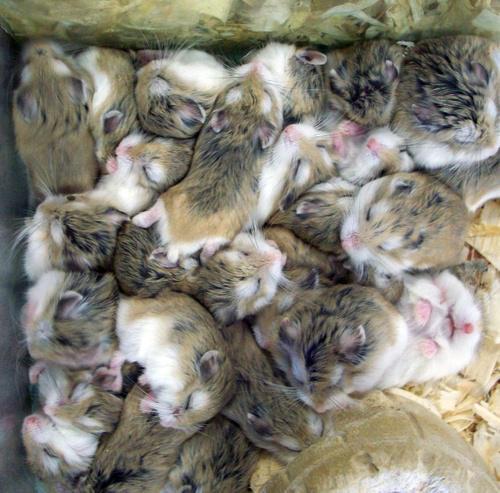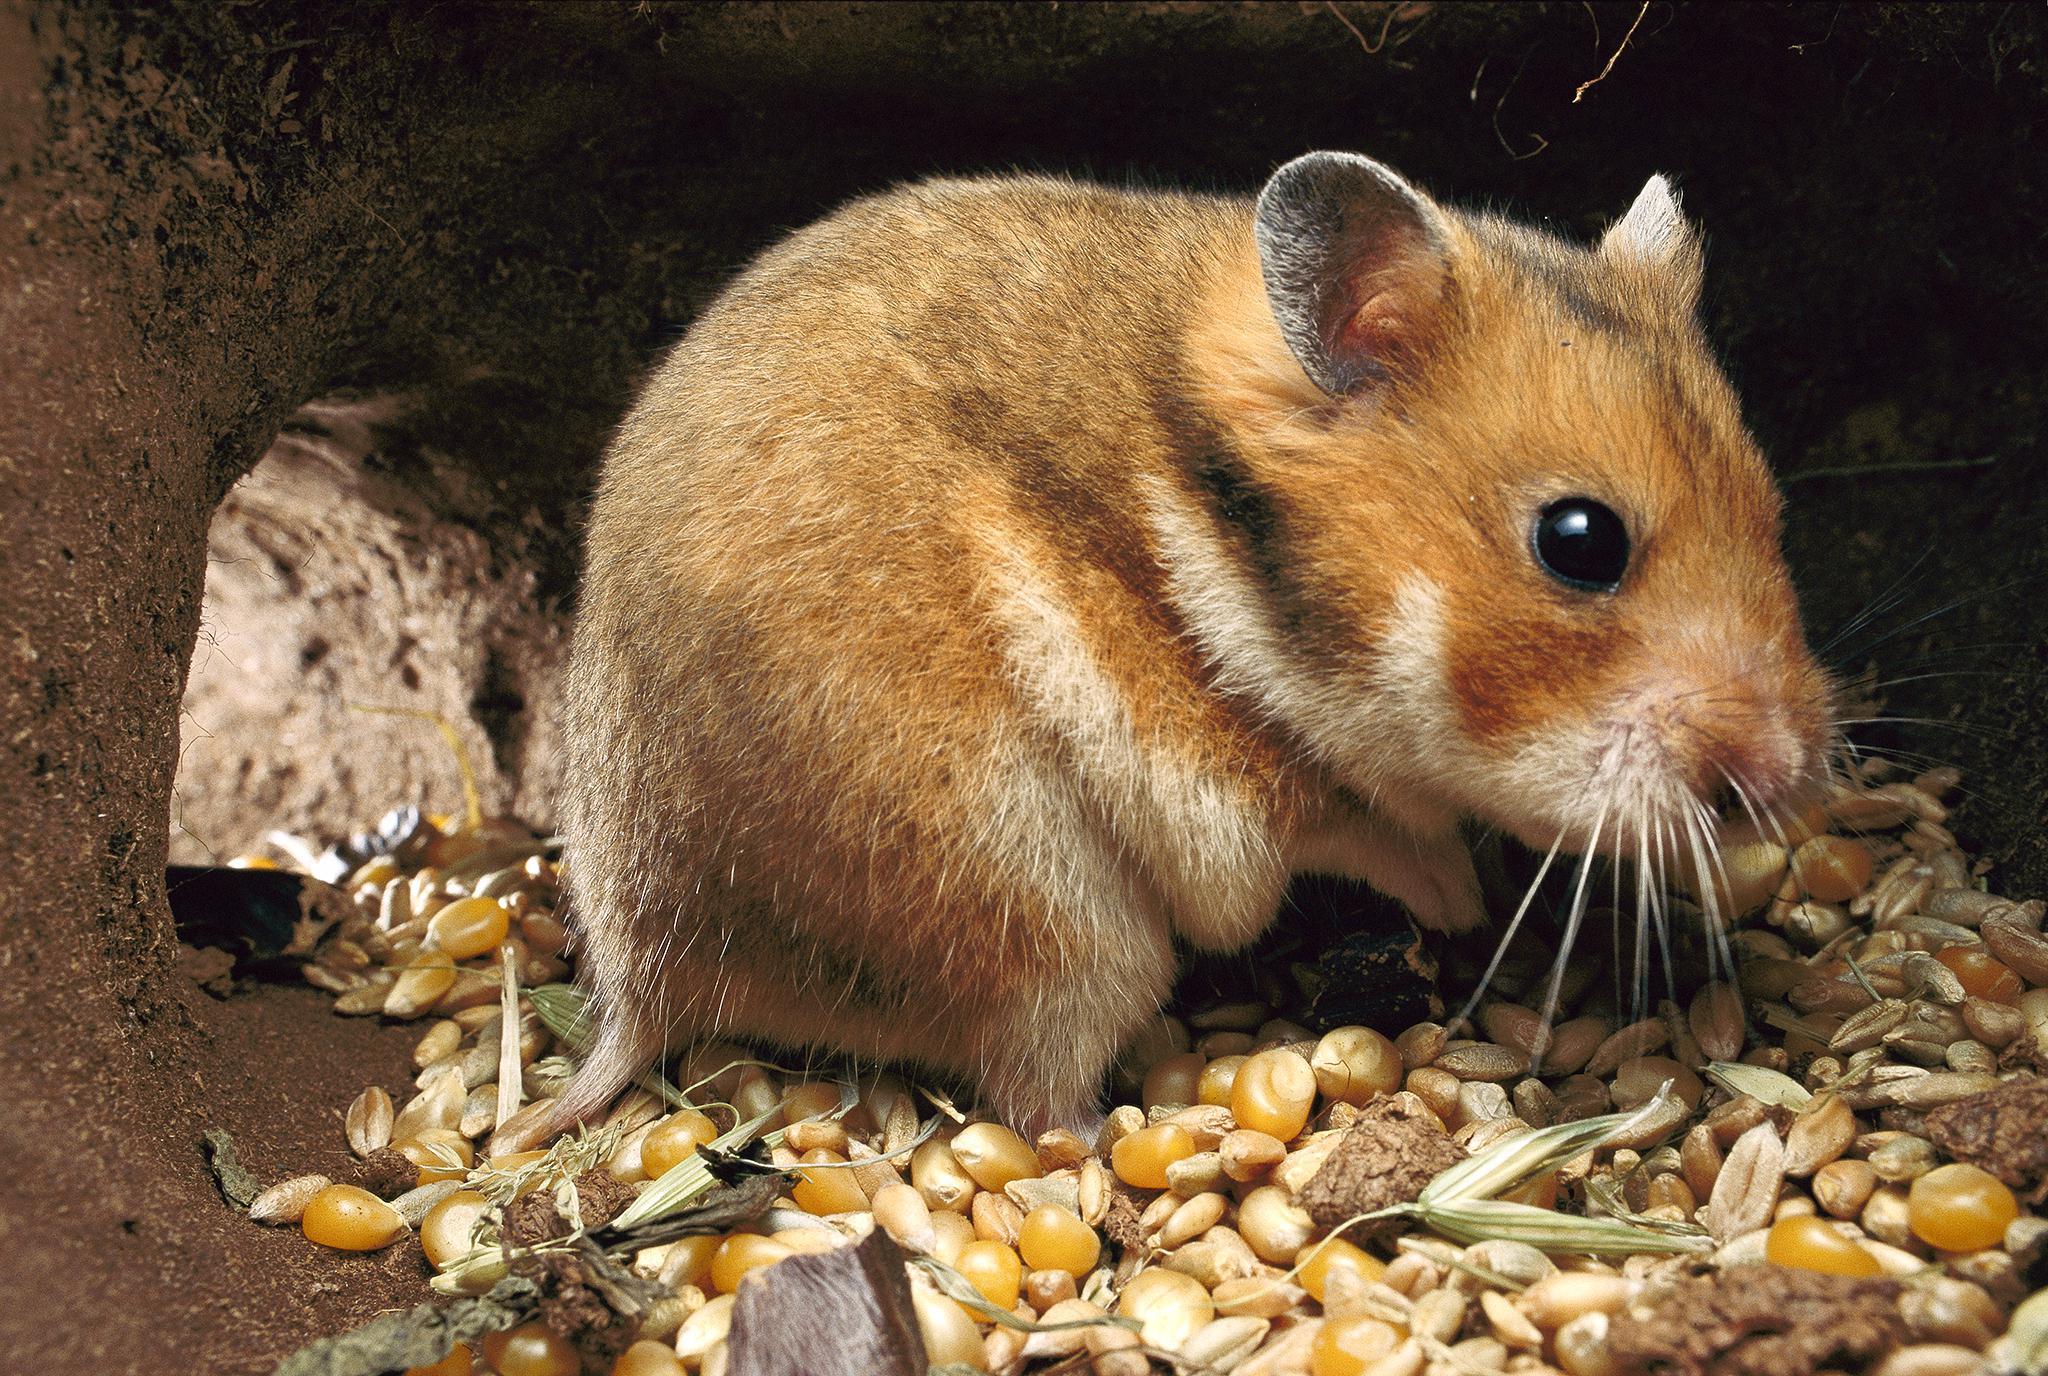The first image is the image on the left, the second image is the image on the right. For the images displayed, is the sentence "There is exactly one rodent in the image on the left." factually correct? Answer yes or no. No. 